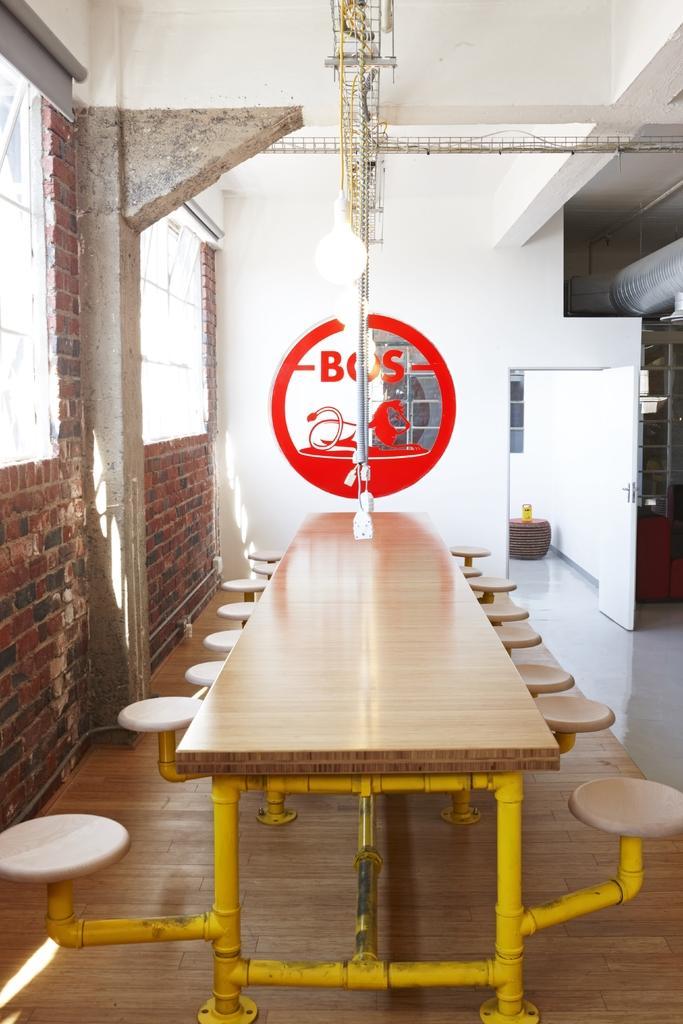How would you summarize this image in a sentence or two? In the center of the image we can see one table with attached stools. In the background there is a wall, windows and a few other objects. 